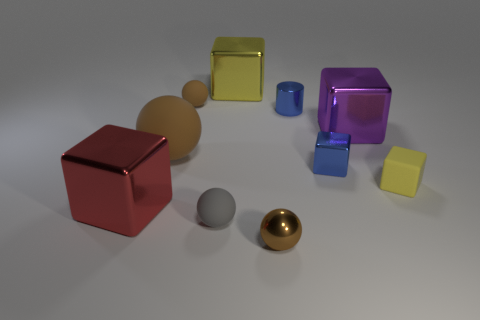What number of other objects are the same shape as the yellow metal thing?
Your answer should be compact. 4. What number of objects are either large metallic cylinders or large metal blocks?
Provide a short and direct response. 3. Is the shiny ball the same color as the big rubber ball?
Offer a very short reply. Yes. There is a big rubber thing that is left of the small yellow object that is behind the red shiny thing; what shape is it?
Provide a short and direct response. Sphere. Is the number of brown metal balls less than the number of small brown balls?
Your response must be concise. Yes. How big is the shiny cube that is both behind the blue block and to the right of the yellow metallic object?
Give a very brief answer. Large. Does the metal sphere have the same size as the yellow metal thing?
Ensure brevity in your answer.  No. Does the tiny metallic object that is in front of the red block have the same color as the big rubber ball?
Ensure brevity in your answer.  Yes. How many tiny brown objects are behind the gray rubber thing?
Provide a short and direct response. 1. Are there more big metallic blocks than big purple cylinders?
Your response must be concise. Yes. 